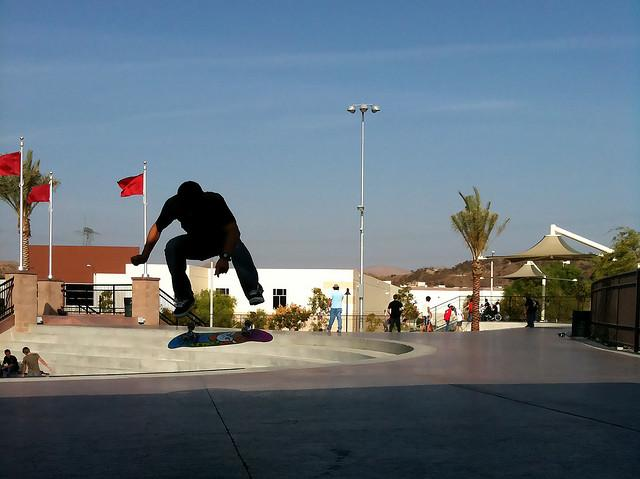What action is he taking with the board? Please explain your reasoning. flip. He is flipping his board over. 